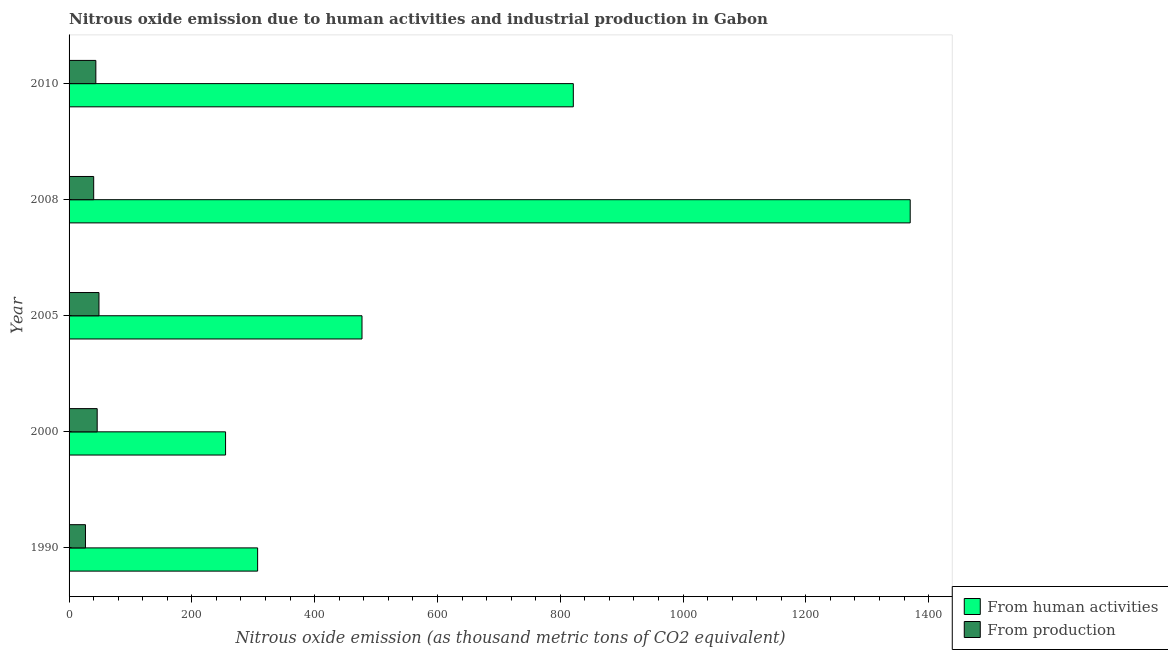How many different coloured bars are there?
Make the answer very short. 2. Are the number of bars on each tick of the Y-axis equal?
Ensure brevity in your answer.  Yes. What is the label of the 5th group of bars from the top?
Provide a succinct answer. 1990. What is the amount of emissions generated from industries in 2010?
Offer a terse response. 43.6. Across all years, what is the maximum amount of emissions generated from industries?
Your answer should be compact. 48.7. Across all years, what is the minimum amount of emissions from human activities?
Your response must be concise. 254.9. What is the total amount of emissions generated from industries in the graph?
Offer a very short reply. 204.9. What is the difference between the amount of emissions from human activities in 2005 and that in 2008?
Ensure brevity in your answer.  -892.9. What is the difference between the amount of emissions generated from industries in 2010 and the amount of emissions from human activities in 1990?
Provide a succinct answer. -263.5. What is the average amount of emissions generated from industries per year?
Your answer should be compact. 40.98. In the year 2005, what is the difference between the amount of emissions from human activities and amount of emissions generated from industries?
Ensure brevity in your answer.  428.4. In how many years, is the amount of emissions from human activities greater than 80 thousand metric tons?
Offer a terse response. 5. What is the ratio of the amount of emissions from human activities in 2000 to that in 2010?
Your answer should be very brief. 0.31. Is the difference between the amount of emissions from human activities in 2008 and 2010 greater than the difference between the amount of emissions generated from industries in 2008 and 2010?
Make the answer very short. Yes. What is the difference between the highest and the second highest amount of emissions generated from industries?
Keep it short and to the point. 2.9. In how many years, is the amount of emissions from human activities greater than the average amount of emissions from human activities taken over all years?
Offer a terse response. 2. Is the sum of the amount of emissions generated from industries in 2000 and 2008 greater than the maximum amount of emissions from human activities across all years?
Provide a succinct answer. No. What does the 2nd bar from the top in 1990 represents?
Your response must be concise. From human activities. What does the 1st bar from the bottom in 2008 represents?
Your answer should be very brief. From human activities. How many bars are there?
Give a very brief answer. 10. Are all the bars in the graph horizontal?
Offer a terse response. Yes. How many years are there in the graph?
Keep it short and to the point. 5. Are the values on the major ticks of X-axis written in scientific E-notation?
Your response must be concise. No. How many legend labels are there?
Offer a terse response. 2. What is the title of the graph?
Offer a very short reply. Nitrous oxide emission due to human activities and industrial production in Gabon. Does "Merchandise exports" appear as one of the legend labels in the graph?
Provide a short and direct response. No. What is the label or title of the X-axis?
Offer a terse response. Nitrous oxide emission (as thousand metric tons of CO2 equivalent). What is the label or title of the Y-axis?
Your response must be concise. Year. What is the Nitrous oxide emission (as thousand metric tons of CO2 equivalent) of From human activities in 1990?
Offer a terse response. 307.1. What is the Nitrous oxide emission (as thousand metric tons of CO2 equivalent) in From production in 1990?
Offer a terse response. 26.7. What is the Nitrous oxide emission (as thousand metric tons of CO2 equivalent) in From human activities in 2000?
Offer a very short reply. 254.9. What is the Nitrous oxide emission (as thousand metric tons of CO2 equivalent) of From production in 2000?
Provide a succinct answer. 45.8. What is the Nitrous oxide emission (as thousand metric tons of CO2 equivalent) in From human activities in 2005?
Your answer should be compact. 477.1. What is the Nitrous oxide emission (as thousand metric tons of CO2 equivalent) in From production in 2005?
Your answer should be very brief. 48.7. What is the Nitrous oxide emission (as thousand metric tons of CO2 equivalent) of From human activities in 2008?
Offer a very short reply. 1370. What is the Nitrous oxide emission (as thousand metric tons of CO2 equivalent) of From production in 2008?
Provide a succinct answer. 40.1. What is the Nitrous oxide emission (as thousand metric tons of CO2 equivalent) of From human activities in 2010?
Your response must be concise. 821.3. What is the Nitrous oxide emission (as thousand metric tons of CO2 equivalent) in From production in 2010?
Your response must be concise. 43.6. Across all years, what is the maximum Nitrous oxide emission (as thousand metric tons of CO2 equivalent) in From human activities?
Offer a terse response. 1370. Across all years, what is the maximum Nitrous oxide emission (as thousand metric tons of CO2 equivalent) of From production?
Give a very brief answer. 48.7. Across all years, what is the minimum Nitrous oxide emission (as thousand metric tons of CO2 equivalent) of From human activities?
Offer a very short reply. 254.9. Across all years, what is the minimum Nitrous oxide emission (as thousand metric tons of CO2 equivalent) of From production?
Give a very brief answer. 26.7. What is the total Nitrous oxide emission (as thousand metric tons of CO2 equivalent) in From human activities in the graph?
Give a very brief answer. 3230.4. What is the total Nitrous oxide emission (as thousand metric tons of CO2 equivalent) of From production in the graph?
Provide a short and direct response. 204.9. What is the difference between the Nitrous oxide emission (as thousand metric tons of CO2 equivalent) of From human activities in 1990 and that in 2000?
Provide a short and direct response. 52.2. What is the difference between the Nitrous oxide emission (as thousand metric tons of CO2 equivalent) in From production in 1990 and that in 2000?
Make the answer very short. -19.1. What is the difference between the Nitrous oxide emission (as thousand metric tons of CO2 equivalent) of From human activities in 1990 and that in 2005?
Your answer should be compact. -170. What is the difference between the Nitrous oxide emission (as thousand metric tons of CO2 equivalent) in From human activities in 1990 and that in 2008?
Keep it short and to the point. -1062.9. What is the difference between the Nitrous oxide emission (as thousand metric tons of CO2 equivalent) of From production in 1990 and that in 2008?
Provide a succinct answer. -13.4. What is the difference between the Nitrous oxide emission (as thousand metric tons of CO2 equivalent) in From human activities in 1990 and that in 2010?
Make the answer very short. -514.2. What is the difference between the Nitrous oxide emission (as thousand metric tons of CO2 equivalent) of From production in 1990 and that in 2010?
Make the answer very short. -16.9. What is the difference between the Nitrous oxide emission (as thousand metric tons of CO2 equivalent) of From human activities in 2000 and that in 2005?
Provide a short and direct response. -222.2. What is the difference between the Nitrous oxide emission (as thousand metric tons of CO2 equivalent) in From human activities in 2000 and that in 2008?
Ensure brevity in your answer.  -1115.1. What is the difference between the Nitrous oxide emission (as thousand metric tons of CO2 equivalent) in From production in 2000 and that in 2008?
Your answer should be very brief. 5.7. What is the difference between the Nitrous oxide emission (as thousand metric tons of CO2 equivalent) in From human activities in 2000 and that in 2010?
Ensure brevity in your answer.  -566.4. What is the difference between the Nitrous oxide emission (as thousand metric tons of CO2 equivalent) in From human activities in 2005 and that in 2008?
Provide a short and direct response. -892.9. What is the difference between the Nitrous oxide emission (as thousand metric tons of CO2 equivalent) of From human activities in 2005 and that in 2010?
Provide a succinct answer. -344.2. What is the difference between the Nitrous oxide emission (as thousand metric tons of CO2 equivalent) of From production in 2005 and that in 2010?
Make the answer very short. 5.1. What is the difference between the Nitrous oxide emission (as thousand metric tons of CO2 equivalent) in From human activities in 2008 and that in 2010?
Ensure brevity in your answer.  548.7. What is the difference between the Nitrous oxide emission (as thousand metric tons of CO2 equivalent) in From production in 2008 and that in 2010?
Your answer should be compact. -3.5. What is the difference between the Nitrous oxide emission (as thousand metric tons of CO2 equivalent) in From human activities in 1990 and the Nitrous oxide emission (as thousand metric tons of CO2 equivalent) in From production in 2000?
Ensure brevity in your answer.  261.3. What is the difference between the Nitrous oxide emission (as thousand metric tons of CO2 equivalent) of From human activities in 1990 and the Nitrous oxide emission (as thousand metric tons of CO2 equivalent) of From production in 2005?
Your response must be concise. 258.4. What is the difference between the Nitrous oxide emission (as thousand metric tons of CO2 equivalent) of From human activities in 1990 and the Nitrous oxide emission (as thousand metric tons of CO2 equivalent) of From production in 2008?
Provide a succinct answer. 267. What is the difference between the Nitrous oxide emission (as thousand metric tons of CO2 equivalent) in From human activities in 1990 and the Nitrous oxide emission (as thousand metric tons of CO2 equivalent) in From production in 2010?
Ensure brevity in your answer.  263.5. What is the difference between the Nitrous oxide emission (as thousand metric tons of CO2 equivalent) of From human activities in 2000 and the Nitrous oxide emission (as thousand metric tons of CO2 equivalent) of From production in 2005?
Ensure brevity in your answer.  206.2. What is the difference between the Nitrous oxide emission (as thousand metric tons of CO2 equivalent) of From human activities in 2000 and the Nitrous oxide emission (as thousand metric tons of CO2 equivalent) of From production in 2008?
Ensure brevity in your answer.  214.8. What is the difference between the Nitrous oxide emission (as thousand metric tons of CO2 equivalent) of From human activities in 2000 and the Nitrous oxide emission (as thousand metric tons of CO2 equivalent) of From production in 2010?
Provide a succinct answer. 211.3. What is the difference between the Nitrous oxide emission (as thousand metric tons of CO2 equivalent) of From human activities in 2005 and the Nitrous oxide emission (as thousand metric tons of CO2 equivalent) of From production in 2008?
Your response must be concise. 437. What is the difference between the Nitrous oxide emission (as thousand metric tons of CO2 equivalent) of From human activities in 2005 and the Nitrous oxide emission (as thousand metric tons of CO2 equivalent) of From production in 2010?
Provide a short and direct response. 433.5. What is the difference between the Nitrous oxide emission (as thousand metric tons of CO2 equivalent) of From human activities in 2008 and the Nitrous oxide emission (as thousand metric tons of CO2 equivalent) of From production in 2010?
Give a very brief answer. 1326.4. What is the average Nitrous oxide emission (as thousand metric tons of CO2 equivalent) in From human activities per year?
Your response must be concise. 646.08. What is the average Nitrous oxide emission (as thousand metric tons of CO2 equivalent) of From production per year?
Offer a terse response. 40.98. In the year 1990, what is the difference between the Nitrous oxide emission (as thousand metric tons of CO2 equivalent) of From human activities and Nitrous oxide emission (as thousand metric tons of CO2 equivalent) of From production?
Make the answer very short. 280.4. In the year 2000, what is the difference between the Nitrous oxide emission (as thousand metric tons of CO2 equivalent) of From human activities and Nitrous oxide emission (as thousand metric tons of CO2 equivalent) of From production?
Keep it short and to the point. 209.1. In the year 2005, what is the difference between the Nitrous oxide emission (as thousand metric tons of CO2 equivalent) of From human activities and Nitrous oxide emission (as thousand metric tons of CO2 equivalent) of From production?
Your response must be concise. 428.4. In the year 2008, what is the difference between the Nitrous oxide emission (as thousand metric tons of CO2 equivalent) of From human activities and Nitrous oxide emission (as thousand metric tons of CO2 equivalent) of From production?
Ensure brevity in your answer.  1329.9. In the year 2010, what is the difference between the Nitrous oxide emission (as thousand metric tons of CO2 equivalent) of From human activities and Nitrous oxide emission (as thousand metric tons of CO2 equivalent) of From production?
Provide a succinct answer. 777.7. What is the ratio of the Nitrous oxide emission (as thousand metric tons of CO2 equivalent) in From human activities in 1990 to that in 2000?
Your answer should be very brief. 1.2. What is the ratio of the Nitrous oxide emission (as thousand metric tons of CO2 equivalent) in From production in 1990 to that in 2000?
Keep it short and to the point. 0.58. What is the ratio of the Nitrous oxide emission (as thousand metric tons of CO2 equivalent) of From human activities in 1990 to that in 2005?
Your response must be concise. 0.64. What is the ratio of the Nitrous oxide emission (as thousand metric tons of CO2 equivalent) of From production in 1990 to that in 2005?
Make the answer very short. 0.55. What is the ratio of the Nitrous oxide emission (as thousand metric tons of CO2 equivalent) in From human activities in 1990 to that in 2008?
Your response must be concise. 0.22. What is the ratio of the Nitrous oxide emission (as thousand metric tons of CO2 equivalent) of From production in 1990 to that in 2008?
Give a very brief answer. 0.67. What is the ratio of the Nitrous oxide emission (as thousand metric tons of CO2 equivalent) of From human activities in 1990 to that in 2010?
Your response must be concise. 0.37. What is the ratio of the Nitrous oxide emission (as thousand metric tons of CO2 equivalent) of From production in 1990 to that in 2010?
Ensure brevity in your answer.  0.61. What is the ratio of the Nitrous oxide emission (as thousand metric tons of CO2 equivalent) in From human activities in 2000 to that in 2005?
Provide a succinct answer. 0.53. What is the ratio of the Nitrous oxide emission (as thousand metric tons of CO2 equivalent) of From production in 2000 to that in 2005?
Your answer should be compact. 0.94. What is the ratio of the Nitrous oxide emission (as thousand metric tons of CO2 equivalent) in From human activities in 2000 to that in 2008?
Your response must be concise. 0.19. What is the ratio of the Nitrous oxide emission (as thousand metric tons of CO2 equivalent) in From production in 2000 to that in 2008?
Provide a succinct answer. 1.14. What is the ratio of the Nitrous oxide emission (as thousand metric tons of CO2 equivalent) in From human activities in 2000 to that in 2010?
Provide a succinct answer. 0.31. What is the ratio of the Nitrous oxide emission (as thousand metric tons of CO2 equivalent) of From production in 2000 to that in 2010?
Provide a short and direct response. 1.05. What is the ratio of the Nitrous oxide emission (as thousand metric tons of CO2 equivalent) in From human activities in 2005 to that in 2008?
Make the answer very short. 0.35. What is the ratio of the Nitrous oxide emission (as thousand metric tons of CO2 equivalent) in From production in 2005 to that in 2008?
Offer a very short reply. 1.21. What is the ratio of the Nitrous oxide emission (as thousand metric tons of CO2 equivalent) of From human activities in 2005 to that in 2010?
Your answer should be very brief. 0.58. What is the ratio of the Nitrous oxide emission (as thousand metric tons of CO2 equivalent) in From production in 2005 to that in 2010?
Your answer should be compact. 1.12. What is the ratio of the Nitrous oxide emission (as thousand metric tons of CO2 equivalent) of From human activities in 2008 to that in 2010?
Provide a succinct answer. 1.67. What is the ratio of the Nitrous oxide emission (as thousand metric tons of CO2 equivalent) of From production in 2008 to that in 2010?
Your response must be concise. 0.92. What is the difference between the highest and the second highest Nitrous oxide emission (as thousand metric tons of CO2 equivalent) of From human activities?
Offer a terse response. 548.7. What is the difference between the highest and the lowest Nitrous oxide emission (as thousand metric tons of CO2 equivalent) in From human activities?
Provide a succinct answer. 1115.1. What is the difference between the highest and the lowest Nitrous oxide emission (as thousand metric tons of CO2 equivalent) of From production?
Give a very brief answer. 22. 